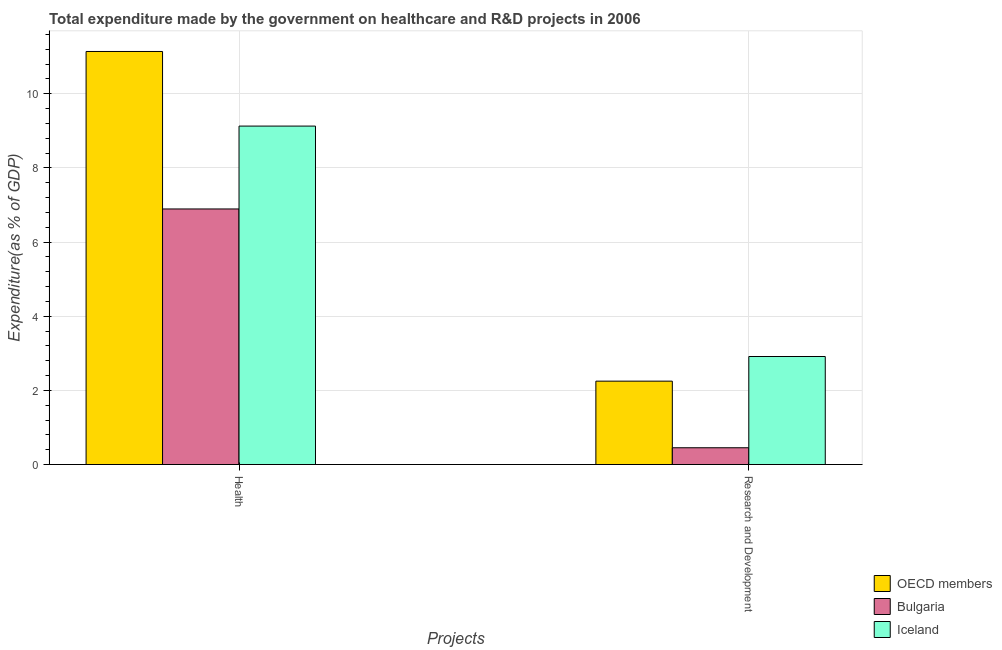How many different coloured bars are there?
Keep it short and to the point. 3. How many groups of bars are there?
Keep it short and to the point. 2. Are the number of bars per tick equal to the number of legend labels?
Provide a succinct answer. Yes. Are the number of bars on each tick of the X-axis equal?
Your response must be concise. Yes. How many bars are there on the 1st tick from the left?
Make the answer very short. 3. How many bars are there on the 2nd tick from the right?
Provide a succinct answer. 3. What is the label of the 2nd group of bars from the left?
Offer a very short reply. Research and Development. What is the expenditure in r&d in Iceland?
Keep it short and to the point. 2.91. Across all countries, what is the maximum expenditure in r&d?
Offer a very short reply. 2.91. Across all countries, what is the minimum expenditure in r&d?
Offer a terse response. 0.45. In which country was the expenditure in healthcare maximum?
Make the answer very short. OECD members. In which country was the expenditure in r&d minimum?
Keep it short and to the point. Bulgaria. What is the total expenditure in healthcare in the graph?
Ensure brevity in your answer.  27.16. What is the difference between the expenditure in r&d in OECD members and that in Bulgaria?
Keep it short and to the point. 1.8. What is the difference between the expenditure in healthcare in OECD members and the expenditure in r&d in Bulgaria?
Your response must be concise. 10.69. What is the average expenditure in healthcare per country?
Provide a short and direct response. 9.05. What is the difference between the expenditure in r&d and expenditure in healthcare in OECD members?
Offer a very short reply. -8.89. In how many countries, is the expenditure in healthcare greater than 6.8 %?
Offer a very short reply. 3. What is the ratio of the expenditure in r&d in Iceland to that in OECD members?
Your answer should be compact. 1.3. How many bars are there?
Give a very brief answer. 6. What is the difference between two consecutive major ticks on the Y-axis?
Provide a succinct answer. 2. Are the values on the major ticks of Y-axis written in scientific E-notation?
Your response must be concise. No. Does the graph contain any zero values?
Your response must be concise. No. How many legend labels are there?
Make the answer very short. 3. How are the legend labels stacked?
Your answer should be compact. Vertical. What is the title of the graph?
Your answer should be compact. Total expenditure made by the government on healthcare and R&D projects in 2006. Does "Isle of Man" appear as one of the legend labels in the graph?
Provide a short and direct response. No. What is the label or title of the X-axis?
Keep it short and to the point. Projects. What is the label or title of the Y-axis?
Give a very brief answer. Expenditure(as % of GDP). What is the Expenditure(as % of GDP) in OECD members in Health?
Make the answer very short. 11.14. What is the Expenditure(as % of GDP) of Bulgaria in Health?
Give a very brief answer. 6.89. What is the Expenditure(as % of GDP) in Iceland in Health?
Offer a very short reply. 9.13. What is the Expenditure(as % of GDP) of OECD members in Research and Development?
Offer a very short reply. 2.25. What is the Expenditure(as % of GDP) of Bulgaria in Research and Development?
Offer a terse response. 0.45. What is the Expenditure(as % of GDP) of Iceland in Research and Development?
Offer a very short reply. 2.91. Across all Projects, what is the maximum Expenditure(as % of GDP) of OECD members?
Make the answer very short. 11.14. Across all Projects, what is the maximum Expenditure(as % of GDP) of Bulgaria?
Give a very brief answer. 6.89. Across all Projects, what is the maximum Expenditure(as % of GDP) of Iceland?
Keep it short and to the point. 9.13. Across all Projects, what is the minimum Expenditure(as % of GDP) of OECD members?
Offer a terse response. 2.25. Across all Projects, what is the minimum Expenditure(as % of GDP) in Bulgaria?
Make the answer very short. 0.45. Across all Projects, what is the minimum Expenditure(as % of GDP) of Iceland?
Provide a succinct answer. 2.91. What is the total Expenditure(as % of GDP) in OECD members in the graph?
Keep it short and to the point. 13.39. What is the total Expenditure(as % of GDP) in Bulgaria in the graph?
Keep it short and to the point. 7.35. What is the total Expenditure(as % of GDP) in Iceland in the graph?
Make the answer very short. 12.04. What is the difference between the Expenditure(as % of GDP) of OECD members in Health and that in Research and Development?
Make the answer very short. 8.89. What is the difference between the Expenditure(as % of GDP) in Bulgaria in Health and that in Research and Development?
Provide a succinct answer. 6.44. What is the difference between the Expenditure(as % of GDP) of Iceland in Health and that in Research and Development?
Give a very brief answer. 6.22. What is the difference between the Expenditure(as % of GDP) in OECD members in Health and the Expenditure(as % of GDP) in Bulgaria in Research and Development?
Offer a very short reply. 10.69. What is the difference between the Expenditure(as % of GDP) of OECD members in Health and the Expenditure(as % of GDP) of Iceland in Research and Development?
Keep it short and to the point. 8.23. What is the difference between the Expenditure(as % of GDP) in Bulgaria in Health and the Expenditure(as % of GDP) in Iceland in Research and Development?
Give a very brief answer. 3.98. What is the average Expenditure(as % of GDP) of OECD members per Projects?
Your response must be concise. 6.7. What is the average Expenditure(as % of GDP) of Bulgaria per Projects?
Keep it short and to the point. 3.67. What is the average Expenditure(as % of GDP) of Iceland per Projects?
Provide a short and direct response. 6.02. What is the difference between the Expenditure(as % of GDP) in OECD members and Expenditure(as % of GDP) in Bulgaria in Health?
Offer a terse response. 4.25. What is the difference between the Expenditure(as % of GDP) of OECD members and Expenditure(as % of GDP) of Iceland in Health?
Your answer should be very brief. 2.01. What is the difference between the Expenditure(as % of GDP) in Bulgaria and Expenditure(as % of GDP) in Iceland in Health?
Your answer should be very brief. -2.24. What is the difference between the Expenditure(as % of GDP) in OECD members and Expenditure(as % of GDP) in Bulgaria in Research and Development?
Offer a very short reply. 1.8. What is the difference between the Expenditure(as % of GDP) in OECD members and Expenditure(as % of GDP) in Iceland in Research and Development?
Make the answer very short. -0.66. What is the difference between the Expenditure(as % of GDP) of Bulgaria and Expenditure(as % of GDP) of Iceland in Research and Development?
Your answer should be very brief. -2.46. What is the ratio of the Expenditure(as % of GDP) of OECD members in Health to that in Research and Development?
Your response must be concise. 4.96. What is the ratio of the Expenditure(as % of GDP) in Bulgaria in Health to that in Research and Development?
Keep it short and to the point. 15.26. What is the ratio of the Expenditure(as % of GDP) in Iceland in Health to that in Research and Development?
Your answer should be very brief. 3.13. What is the difference between the highest and the second highest Expenditure(as % of GDP) in OECD members?
Give a very brief answer. 8.89. What is the difference between the highest and the second highest Expenditure(as % of GDP) of Bulgaria?
Your answer should be compact. 6.44. What is the difference between the highest and the second highest Expenditure(as % of GDP) of Iceland?
Keep it short and to the point. 6.22. What is the difference between the highest and the lowest Expenditure(as % of GDP) in OECD members?
Provide a short and direct response. 8.89. What is the difference between the highest and the lowest Expenditure(as % of GDP) in Bulgaria?
Your response must be concise. 6.44. What is the difference between the highest and the lowest Expenditure(as % of GDP) in Iceland?
Ensure brevity in your answer.  6.22. 